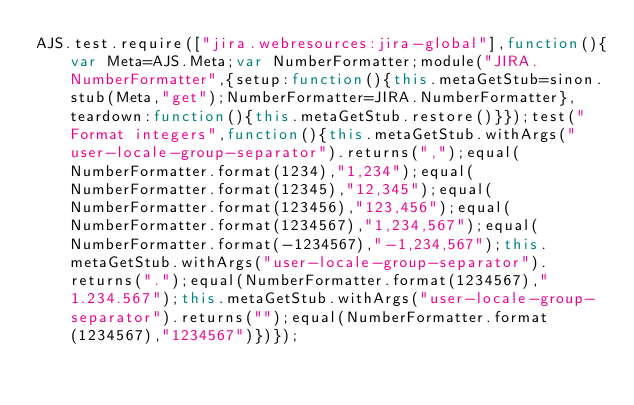<code> <loc_0><loc_0><loc_500><loc_500><_JavaScript_>AJS.test.require(["jira.webresources:jira-global"],function(){var Meta=AJS.Meta;var NumberFormatter;module("JIRA.NumberFormatter",{setup:function(){this.metaGetStub=sinon.stub(Meta,"get");NumberFormatter=JIRA.NumberFormatter},teardown:function(){this.metaGetStub.restore()}});test("Format integers",function(){this.metaGetStub.withArgs("user-locale-group-separator").returns(",");equal(NumberFormatter.format(1234),"1,234");equal(NumberFormatter.format(12345),"12,345");equal(NumberFormatter.format(123456),"123,456");equal(NumberFormatter.format(1234567),"1,234,567");equal(NumberFormatter.format(-1234567),"-1,234,567");this.metaGetStub.withArgs("user-locale-group-separator").returns(".");equal(NumberFormatter.format(1234567),"1.234.567");this.metaGetStub.withArgs("user-locale-group-separator").returns("");equal(NumberFormatter.format(1234567),"1234567")})});</code> 